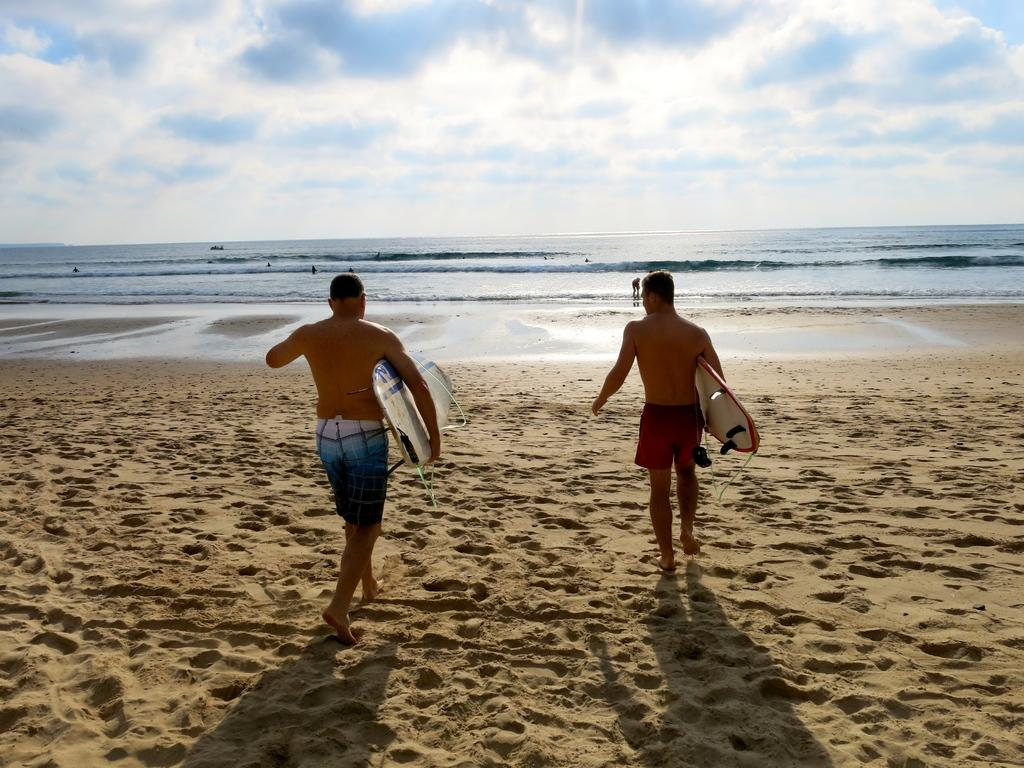How many people are in the image? There are two men in the image. What are the men holding in their hands? The men are holding boards in their hands. What direction are the men walking in? The men are walking towards the ocean. What is the color of the sky in the background of the image? The sky in the background of the image is blue. What type of crown is the man wearing on his head in the image? There is no crown present in the image; the men are holding boards and walking towards the ocean. 